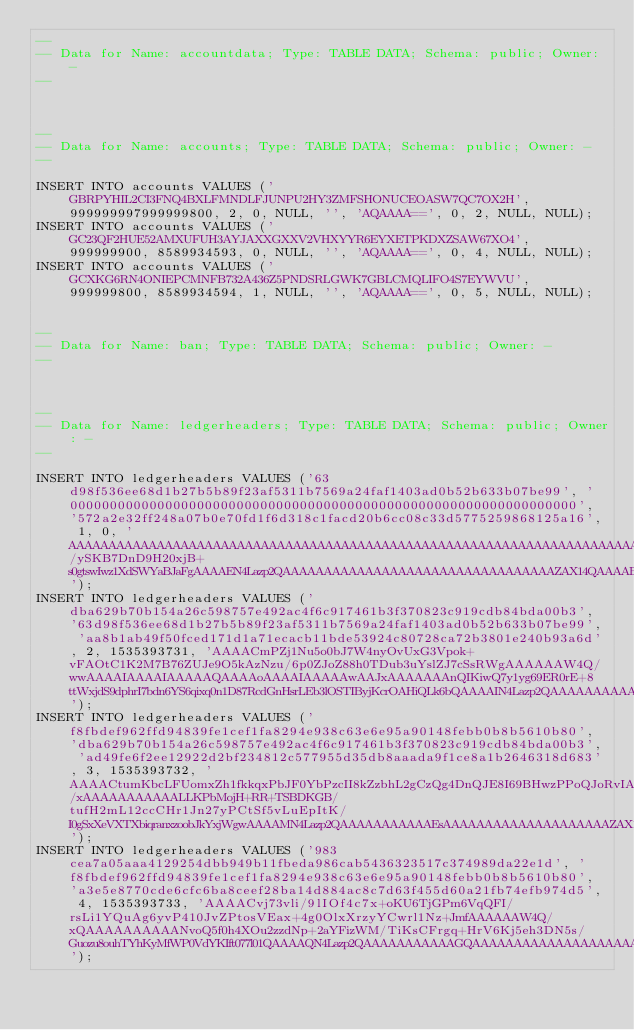Convert code to text. <code><loc_0><loc_0><loc_500><loc_500><_SQL_>--
-- Data for Name: accountdata; Type: TABLE DATA; Schema: public; Owner: -
--



--
-- Data for Name: accounts; Type: TABLE DATA; Schema: public; Owner: -
--

INSERT INTO accounts VALUES ('GBRPYHIL2CI3FNQ4BXLFMNDLFJUNPU2HY3ZMFSHONUCEOASW7QC7OX2H', 999999997999999800, 2, 0, NULL, '', 'AQAAAA==', 0, 2, NULL, NULL);
INSERT INTO accounts VALUES ('GC23QF2HUE52AMXUFUH3AYJAXXGXXV2VHXYYR6EYXETPKDXZSAW67XO4', 999999900, 8589934593, 0, NULL, '', 'AQAAAA==', 0, 4, NULL, NULL);
INSERT INTO accounts VALUES ('GCXKG6RN4ONIEPCMNFB732A436Z5PNDSRLGWK7GBLCMQLIFO4S7EYWVU', 999999800, 8589934594, 1, NULL, '', 'AQAAAA==', 0, 5, NULL, NULL);


--
-- Data for Name: ban; Type: TABLE DATA; Schema: public; Owner: -
--



--
-- Data for Name: ledgerheaders; Type: TABLE DATA; Schema: public; Owner: -
--

INSERT INTO ledgerheaders VALUES ('63d98f536ee68d1b27b5b89f23af5311b7569a24faf1403ad0b52b633b07be99', '0000000000000000000000000000000000000000000000000000000000000000', '572a2e32ff248a07b0e70fd1f6d318c1facd20b6cc08c33d5775259868125a16', 1, 0, 'AAAAAAAAAAAAAAAAAAAAAAAAAAAAAAAAAAAAAAAAAAAAAAAAAAAAAAAAAAAAAAAAAAAAAAAAAAAAAAAAAAAAAAAAAAAAAAAAAAAAAAAAAAAAAAAAAAAAAAAAAAAAAAAAAAAAAAAAAAAAAAAAAAAAAAAAAABXKi4y/ySKB7DnD9H20xjB+s0gtswIwz1XdSWYaBJaFgAAAAEN4Lazp2QAAAAAAAAAAAAAAAAAAAAAAAAAAAAAAAAAZAX14QAAAABkAAAAAAAAAAAAAAAAAAAAAAAAAAAAAAAAAAAAAAAAAAAAAAAAAAAAAAAAAAAAAAAAAAAAAAAAAAAAAAAAAAAAAAAAAAAAAAAAAAAAAAAAAAAAAAAAAAAAAAAAAAAAAAAAAAAAAAAAAAAAAAAAAAAAAAAAAAAAAAAAAAAAAAAAAAAAAAAA');
INSERT INTO ledgerheaders VALUES ('dba629b70b154a26c598757e492ac4f6c917461b3f370823c919cdb84bda00b3', '63d98f536ee68d1b27b5b89f23af5311b7569a24faf1403ad0b52b633b07be99', 'aa8b1ab49f50fced171d1a71ecacb11bde53924c80728ca72b3801e240b93a6d', 2, 1535393731, 'AAAACmPZj1Nu5o0bJ7W4nyOvUxG3Vpok+vFAOtC1K2M7B76ZUJe9O5kAzNzu/6p0ZJoZ88h0TDub3uYslZJ7cSsRWgAAAAAAW4Q/wwAAAAIAAAAIAAAAAQAAAAoAAAAIAAAAAwAAJxAAAAAAAnQIKiwQ7y1yg69ER0rE+8ttWxjdS9dphrI7bdn6YS6qixq0n1D87RcdGnHsrLEb3lOSTIByjKcrOAHiQLk6bQAAAAIN4Lazp2QAAAAAAAAAAADIAAAAAAAAAAAAAAAAAAAAZAX14QAAACcQAAAAAAAAAAAAAAAAAAAAAAAAAAAAAAAAAAAAAAAAAAAAAAAAAAAAAAAAAAAAAAAAAAAAAAAAAAAAAAAAAAAAAAAAAAAAAAAAAAAAAAAAAAAAAAAAAAAAAAAAAAAAAAAAAAAAAAAAAAAAAAAAAAAAAAAAAAAAAAAAAAAAAAAAAAAAAAAA');
INSERT INTO ledgerheaders VALUES ('f8fbdef962ffd94839fe1cef1fa8294e938c63e6e95a90148febb0b8b5610b80', 'dba629b70b154a26c598757e492ac4f6c917461b3f370823c919cdb84bda00b3', 'ad49fe6f2ee12922d2bf234812c577955d35db8aaada9f1ce8a1b2646318d683', 3, 1535393732, 'AAAACtumKbcLFUomxZh1fkkqxPbJF0YbPzcII8kZzbhL2gCzQg4DnQJE8I69BHwzPPoQJoRvIAdhBtcT0ZASQsDWmYkAAAAAW4Q/xAAAAAAAAAAALLKPbMojH+RR+TSBDKGB/tufH2mL12ccCHr1Jn27yPCtSf5vLuEpItK/I0gSxXeVXTXbiqranxzoobJkYxjWgwAAAAMN4Lazp2QAAAAAAAAAAAEsAAAAAAAAAAAAAAAAAAAAZAX14QAAACcQAAAAAAAAAAAAAAAAAAAAAAAAAAAAAAAAAAAAAAAAAAAAAAAAAAAAAAAAAAAAAAAAAAAAAAAAAAAAAAAAAAAAAAAAAAAAAAAAAAAAAAAAAAAAAAAAAAAAAAAAAAAAAAAAAAAAAAAAAAAAAAAAAAAAAAAAAAAAAAAAAAAAAAAAAAAAAAAA');
INSERT INTO ledgerheaders VALUES ('983cea7a05aaa4129254dbb949b11fbeda986cab5436323517c374989da22e1d', 'f8fbdef962ffd94839fe1cef1fa8294e938c63e6e95a90148febb0b8b5610b80', 'a3e5e8770cde6cfc6ba8ceef28ba14d884ac8c7d63f455d60a21fb74efb974d5', 4, 1535393733, 'AAAACvj73vli/9lIOf4c7x+oKU6TjGPm6VqQFI/rsLi1YQuAg6yvP410JvZPtosVEax+4g0OlxXrzyYCwrl1Nz+JmfAAAAAAW4Q/xQAAAAAAAAAANvoQ5f0h4XOu2zzdNp+2aYFizWM/TiKsCFrgq+HrV6Kj5eh3DN5s/Guozu8ouhTYhKyMfWP0VdYKIft077l01QAAAAQN4Lazp2QAAAAAAAAAAAGQAAAAAAAAAAAAAAAAAAAAZAX14QAAACcQAAAAAAAAAAAAAAAAAAAAAAAAAAAAAAAAAAAAAAAAAAAAAAAAAAAAAAAAAAAAAAAAAAAAAAAAAAAAAAAAAAAAAAAAAAAAAAAAAAAAAAAAAAAAAAAAAAAAAAAAAAAAAAAAAAAAAAAAAAAAAAAAAAAAAAAAAAAAAAAAAAAAAAAAAAAAAAAA');</code> 